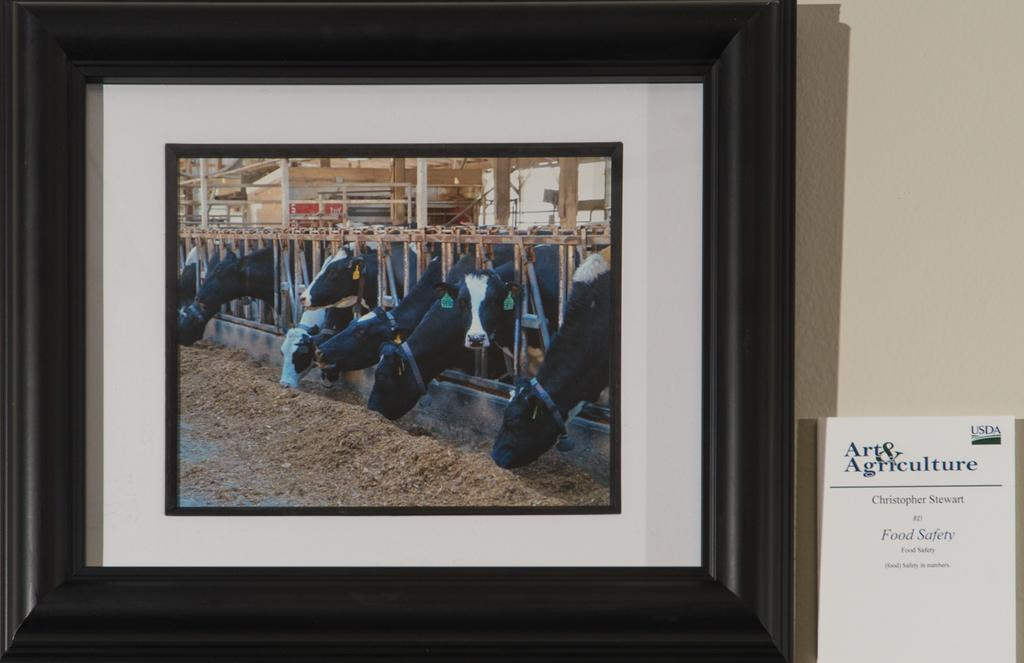What is hanging on the wall in the image? There is a picture frame on the wall. What is depicted inside the picture frame? The picture frame contains animals. What else can be seen on the wall in the image? There is a paper with text on the right side of the wall. Where is the tray located in the image? There is no tray present in the image. Can you describe the garden visible through the window in the image? There is no window or garden visible in the image. 